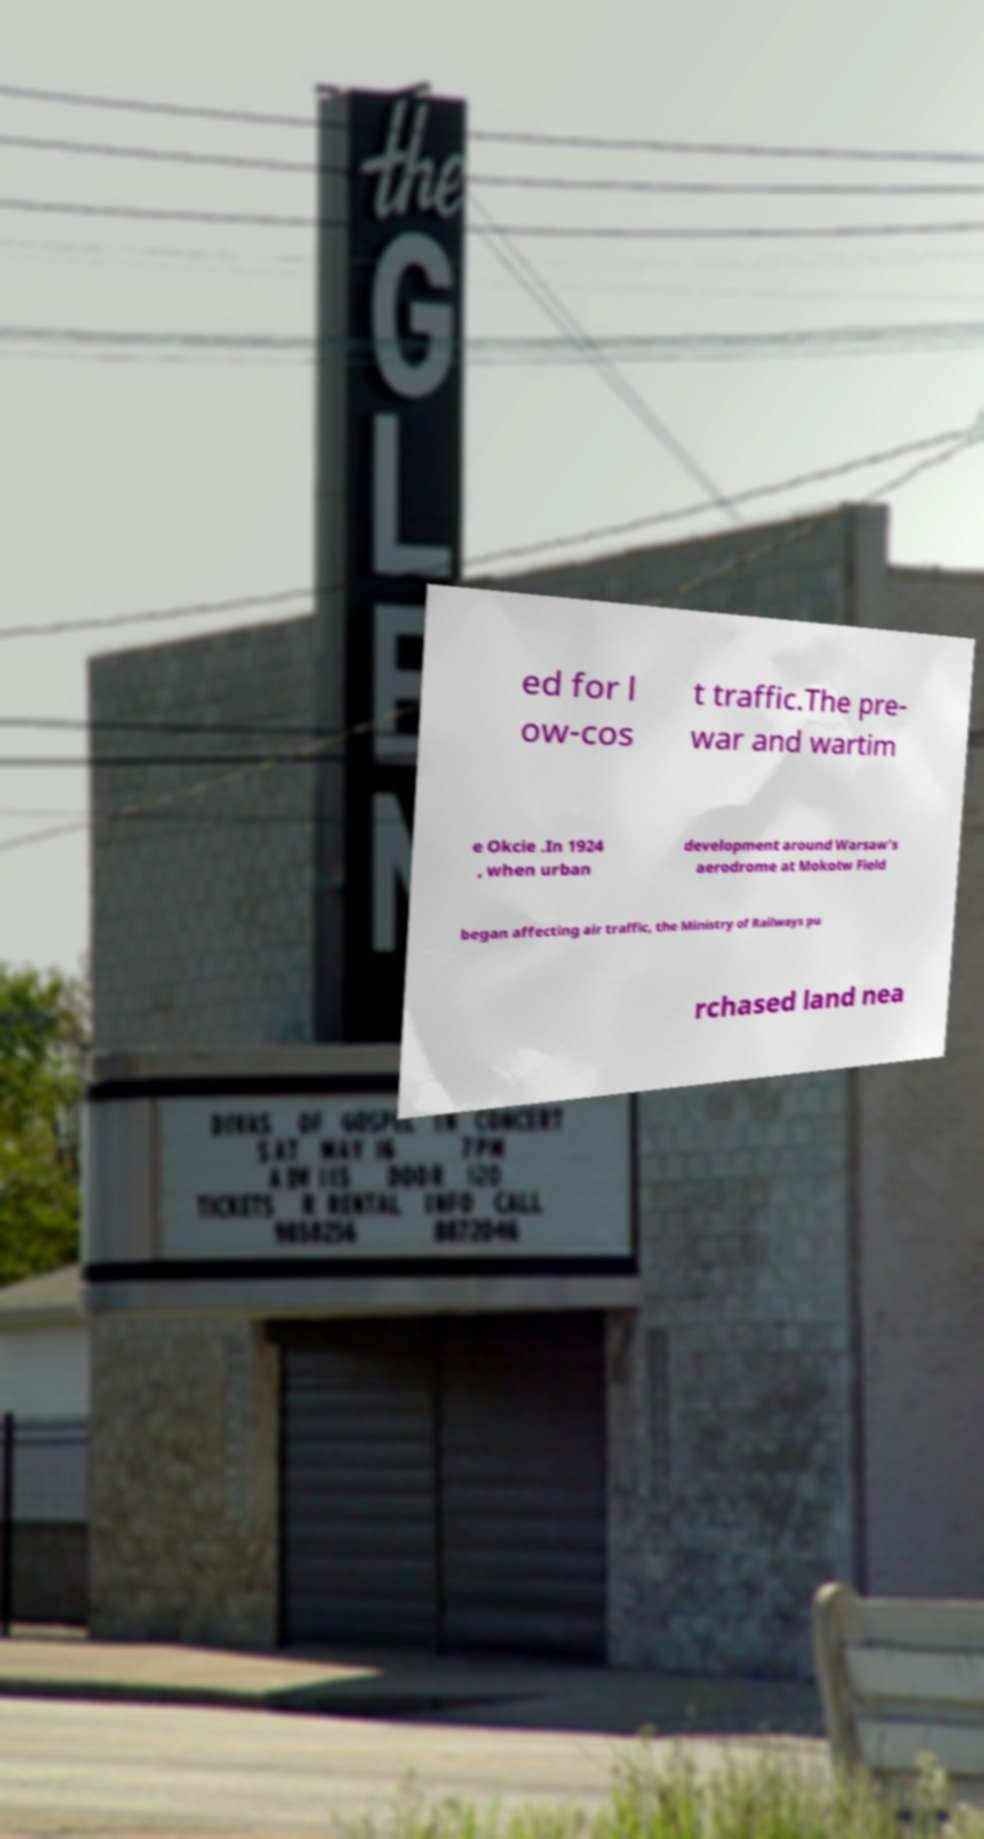Can you read and provide the text displayed in the image?This photo seems to have some interesting text. Can you extract and type it out for me? ed for l ow-cos t traffic.The pre- war and wartim e Okcie .In 1924 , when urban development around Warsaw's aerodrome at Mokotw Field began affecting air traffic, the Ministry of Railways pu rchased land nea 